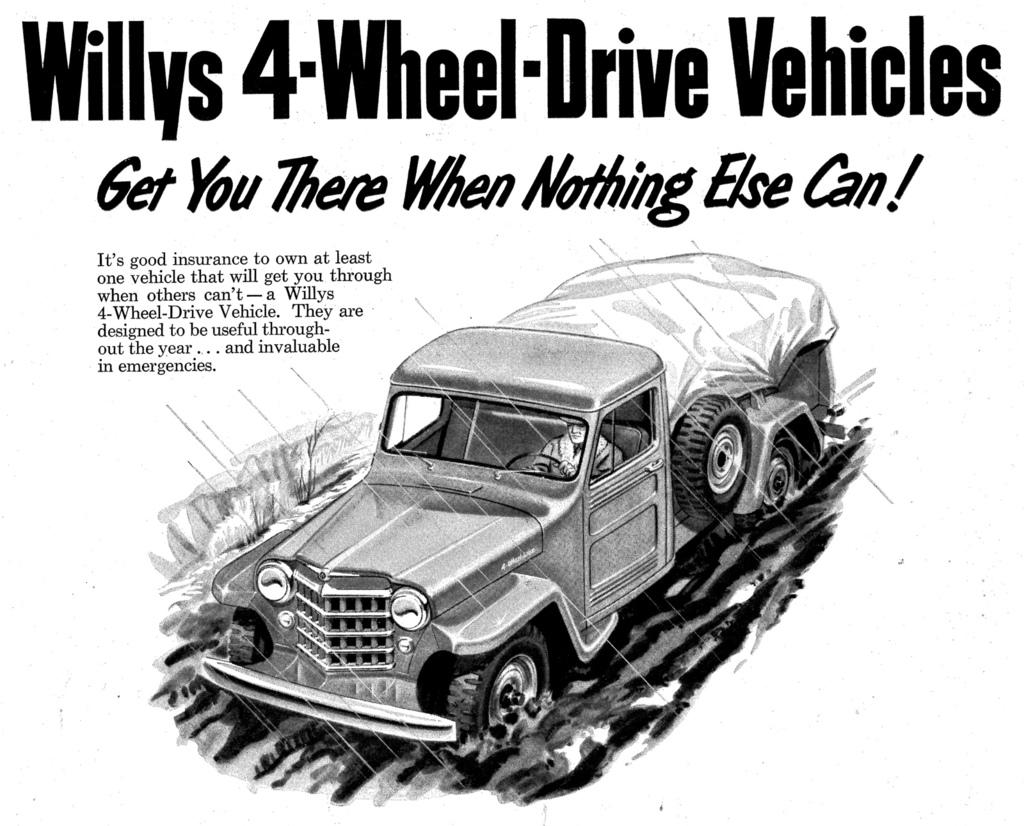What is the main subject of the image? The main subject of the image is a person inside a vehicle. Can you describe the person's surroundings? There is some information visible in the image, but it is not clear what specific information is being referred to. What type of meat is the doctor preparing in the image? There is no doctor or meat present in the image; it features a person inside a vehicle. 